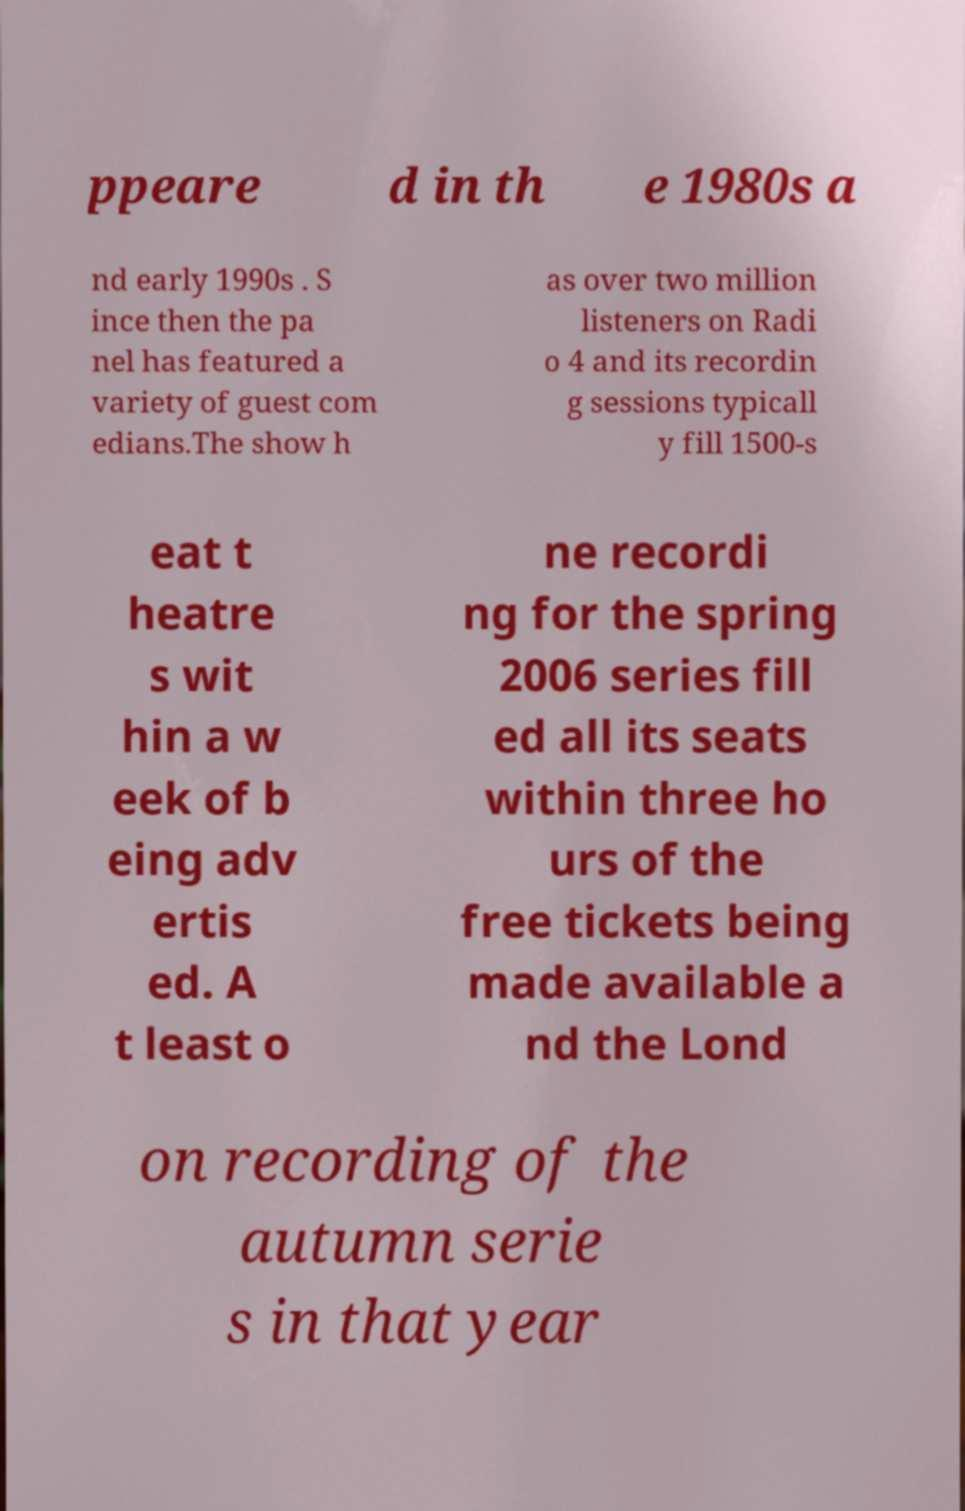Could you extract and type out the text from this image? ppeare d in th e 1980s a nd early 1990s . S ince then the pa nel has featured a variety of guest com edians.The show h as over two million listeners on Radi o 4 and its recordin g sessions typicall y fill 1500-s eat t heatre s wit hin a w eek of b eing adv ertis ed. A t least o ne recordi ng for the spring 2006 series fill ed all its seats within three ho urs of the free tickets being made available a nd the Lond on recording of the autumn serie s in that year 